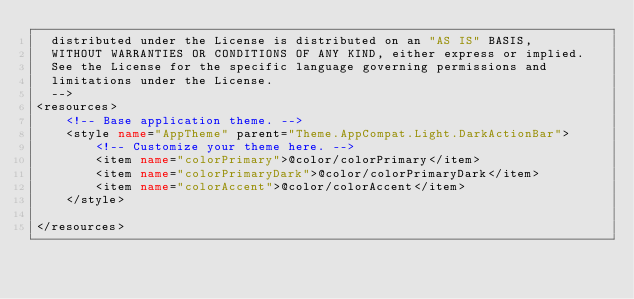Convert code to text. <code><loc_0><loc_0><loc_500><loc_500><_XML_>  distributed under the License is distributed on an "AS IS" BASIS,
  WITHOUT WARRANTIES OR CONDITIONS OF ANY KIND, either express or implied.
  See the License for the specific language governing permissions and
  limitations under the License.
  -->
<resources>
    <!-- Base application theme. -->
    <style name="AppTheme" parent="Theme.AppCompat.Light.DarkActionBar">
        <!-- Customize your theme here. -->
        <item name="colorPrimary">@color/colorPrimary</item>
        <item name="colorPrimaryDark">@color/colorPrimaryDark</item>
        <item name="colorAccent">@color/colorAccent</item>
    </style>

</resources>
</code> 